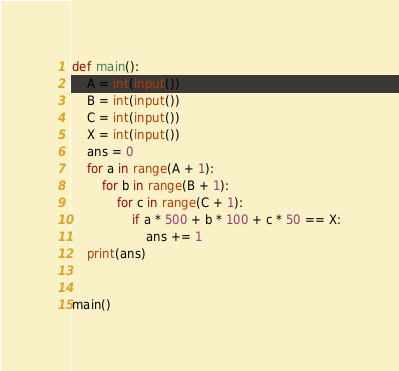Convert code to text. <code><loc_0><loc_0><loc_500><loc_500><_Python_>def main():
    A = int(input())
    B = int(input())
    C = int(input())
    X = int(input())
    ans = 0
    for a in range(A + 1):
        for b in range(B + 1):
            for c in range(C + 1):
                if a * 500 + b * 100 + c * 50 == X:
                    ans += 1
    print(ans)


main()
</code> 